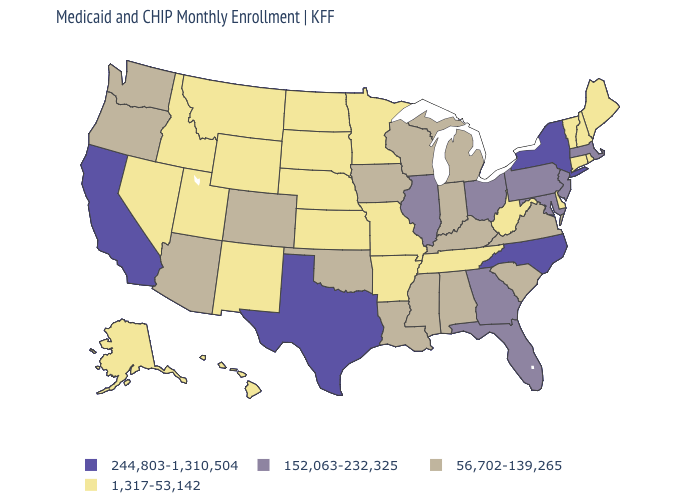What is the value of Indiana?
Quick response, please. 56,702-139,265. Is the legend a continuous bar?
Quick response, please. No. What is the highest value in the USA?
Write a very short answer. 244,803-1,310,504. Name the states that have a value in the range 56,702-139,265?
Be succinct. Alabama, Arizona, Colorado, Indiana, Iowa, Kentucky, Louisiana, Michigan, Mississippi, Oklahoma, Oregon, South Carolina, Virginia, Washington, Wisconsin. Name the states that have a value in the range 244,803-1,310,504?
Answer briefly. California, New York, North Carolina, Texas. Which states have the lowest value in the USA?
Answer briefly. Alaska, Arkansas, Connecticut, Delaware, Hawaii, Idaho, Kansas, Maine, Minnesota, Missouri, Montana, Nebraska, Nevada, New Hampshire, New Mexico, North Dakota, Rhode Island, South Dakota, Tennessee, Utah, Vermont, West Virginia, Wyoming. What is the value of Tennessee?
Short answer required. 1,317-53,142. What is the value of Kansas?
Quick response, please. 1,317-53,142. Is the legend a continuous bar?
Give a very brief answer. No. What is the value of Minnesota?
Write a very short answer. 1,317-53,142. Does Idaho have the same value as Michigan?
Be succinct. No. Name the states that have a value in the range 152,063-232,325?
Short answer required. Florida, Georgia, Illinois, Maryland, Massachusetts, New Jersey, Ohio, Pennsylvania. What is the highest value in the USA?
Give a very brief answer. 244,803-1,310,504. What is the highest value in the South ?
Short answer required. 244,803-1,310,504. Does the first symbol in the legend represent the smallest category?
Short answer required. No. 